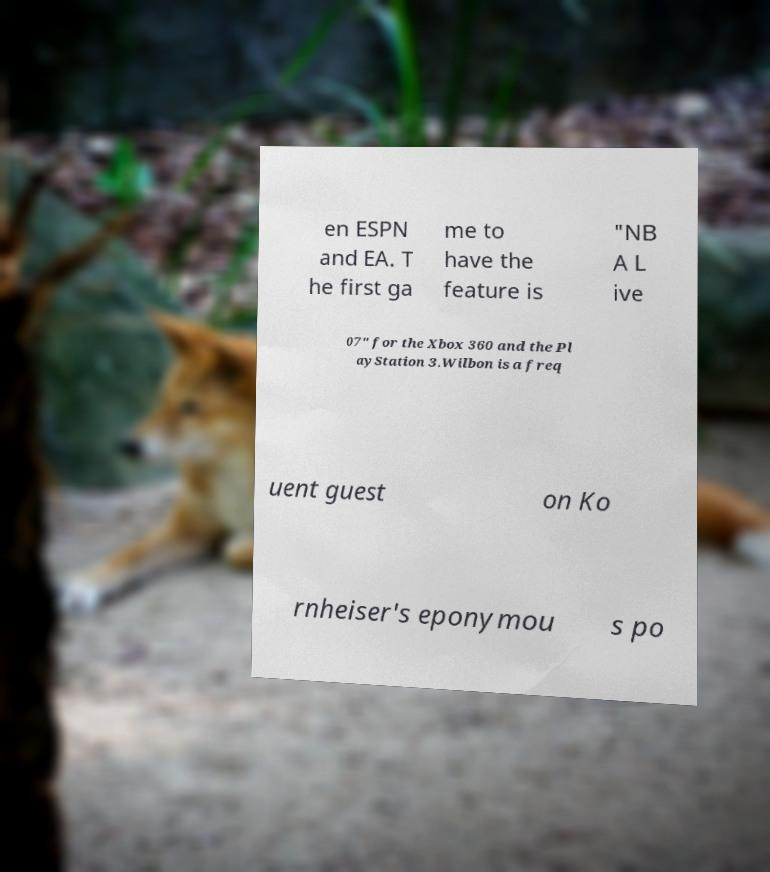Could you assist in decoding the text presented in this image and type it out clearly? en ESPN and EA. T he first ga me to have the feature is "NB A L ive 07" for the Xbox 360 and the Pl ayStation 3.Wilbon is a freq uent guest on Ko rnheiser's eponymou s po 